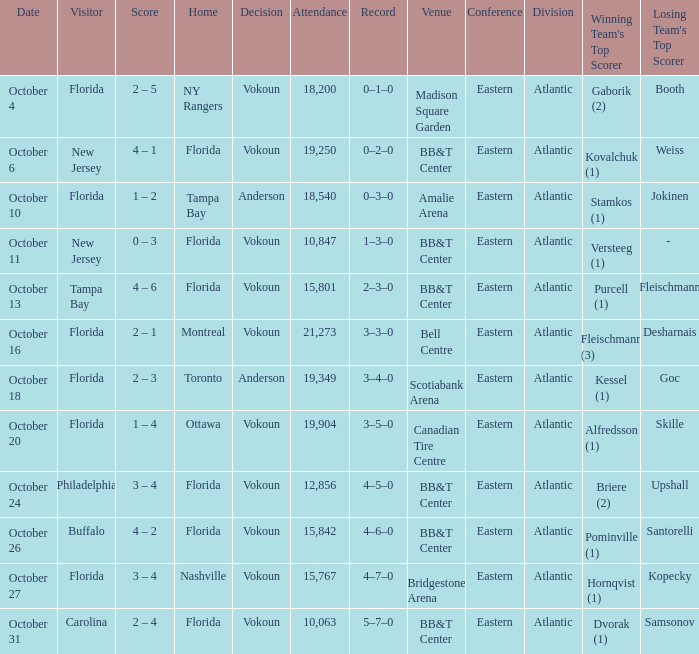Can you tell me the score for october 31st? 2 – 4. 